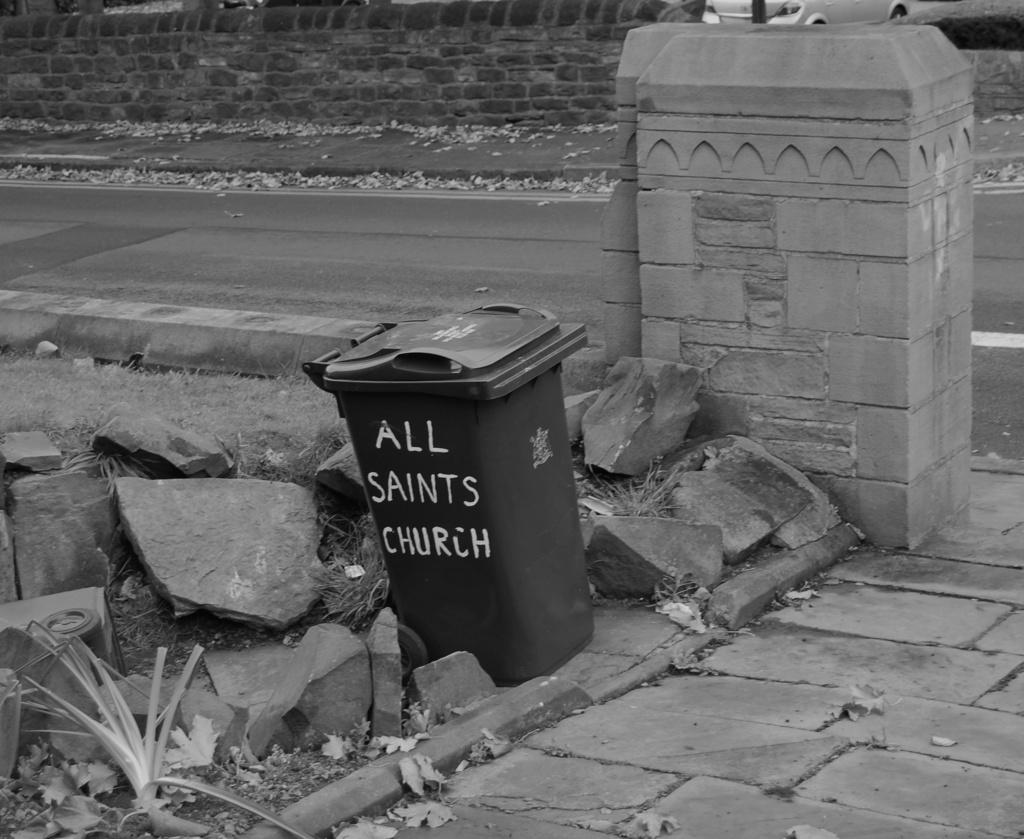What church does this trash can belong to?
Give a very brief answer. All saints church. What colour is this?
Provide a short and direct response. Answering does not require reading text in the image. 